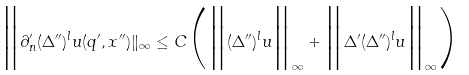<formula> <loc_0><loc_0><loc_500><loc_500>\Big \| \partial ^ { \prime } _ { n } ( \Delta ^ { \prime \prime } ) ^ { l } u ( q ^ { \prime } , x ^ { \prime \prime } ) \| _ { \infty } \leq C \Big ( \Big \| ( \Delta ^ { \prime \prime } ) ^ { l } u \Big \| _ { \infty } + \Big \| \Delta ^ { \prime } ( \Delta ^ { \prime \prime } ) ^ { l } u \Big \| _ { \infty } \Big )</formula> 